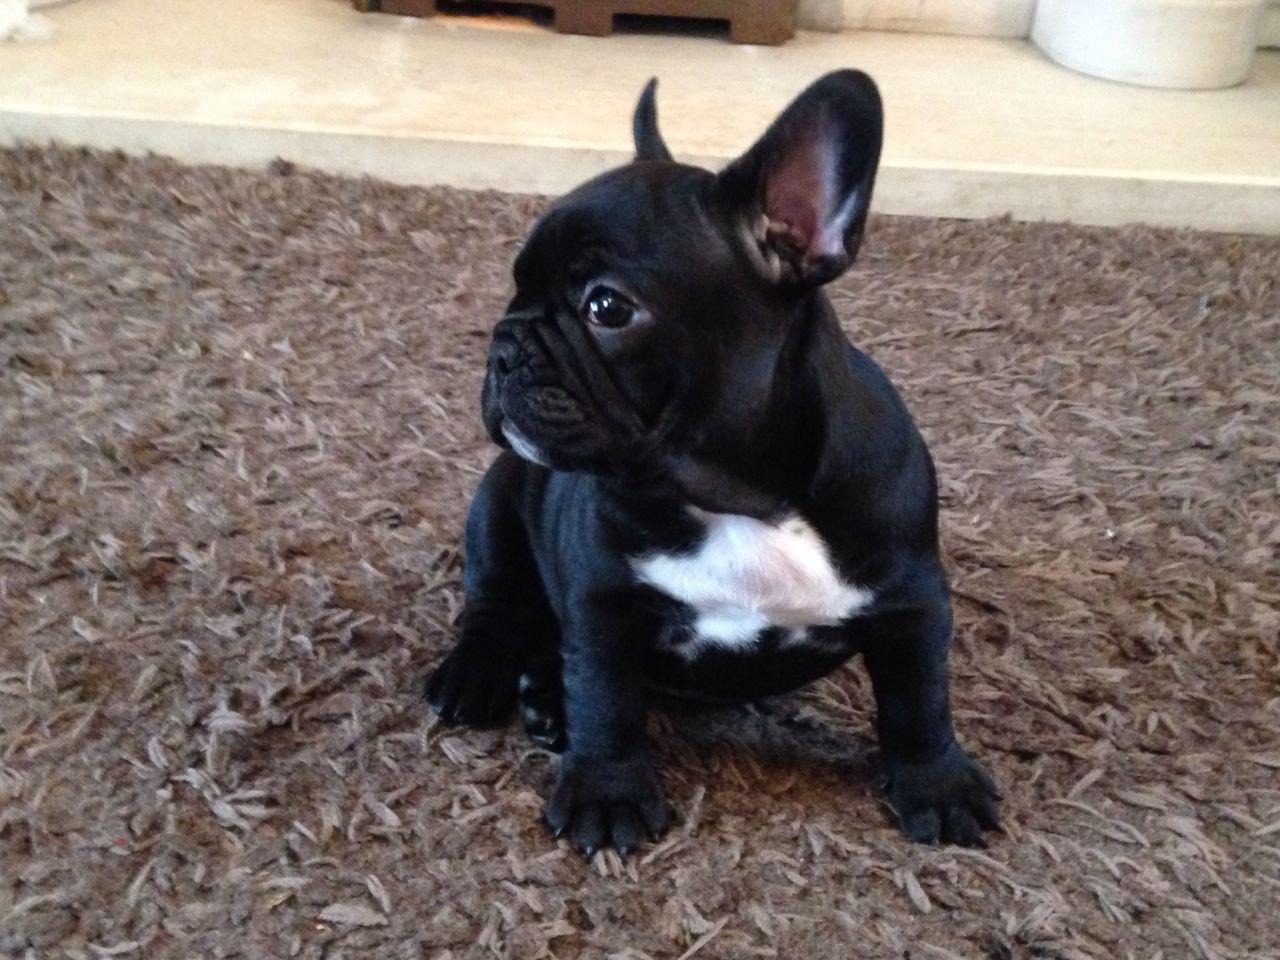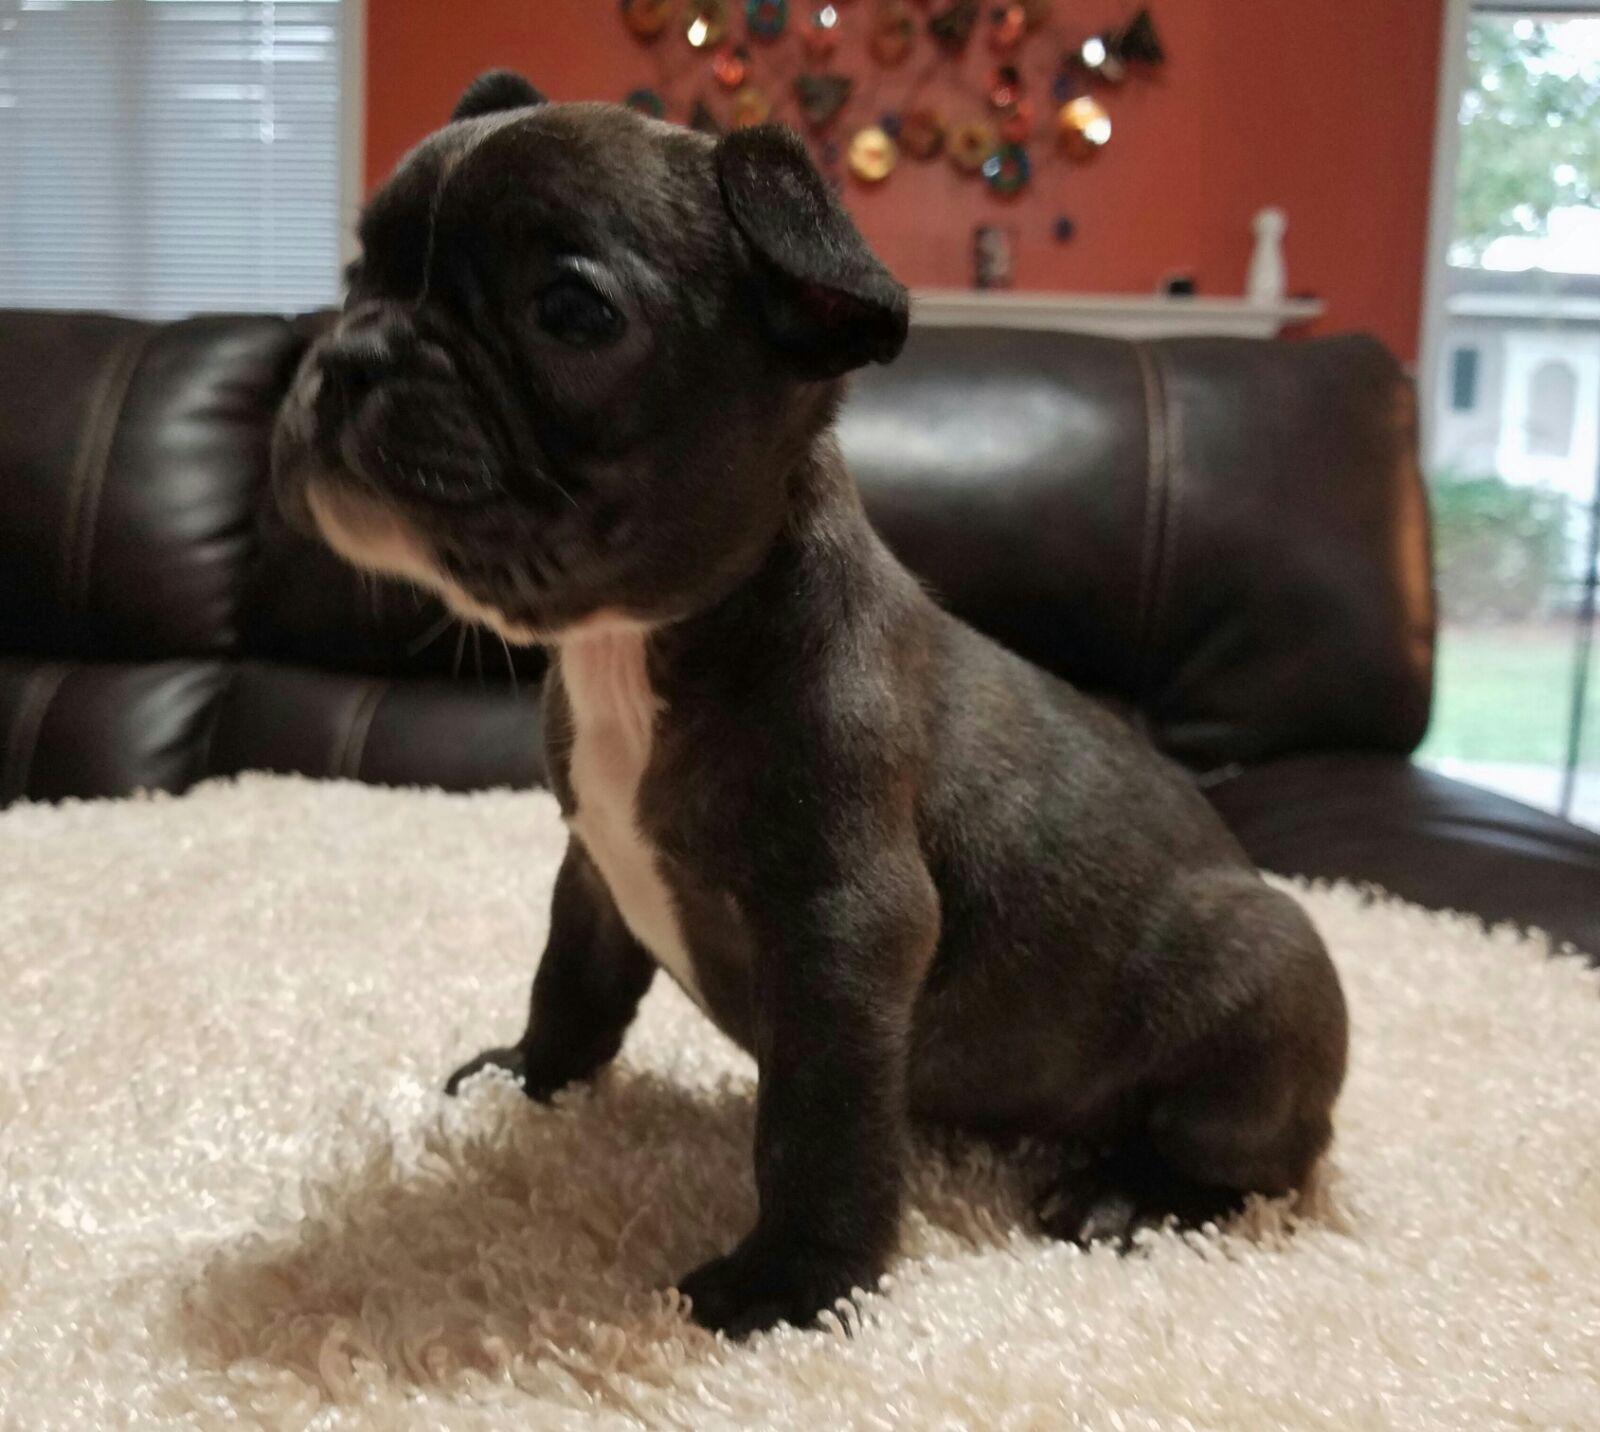The first image is the image on the left, the second image is the image on the right. Assess this claim about the two images: "An image shows a black dog with some type of toy in the side of its mouth.". Correct or not? Answer yes or no. No. 